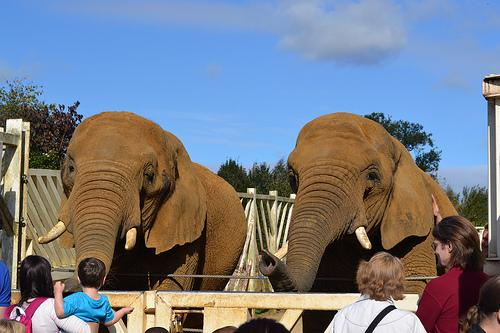Explain the interaction between the elephants and their surroundings. Two elephants stand behind a white metal fence with diagonal slats in their zoo enclosure, surrounded by green trees and observed by visitors. Write a brief description of the scene in the image. Two elephants are relaxing in a zoo enclosure, surrounded by a white fence and leafy trees, as several people, including a mother and child and a young boy in a blue shirt, look on. Describe the fencing that separates the elephants from the people. The fence is made of white metal and has diagonal slats, covering a width of 487 and height of 487. Provide a short description of the vegetation in the image. The image contains green leafy trees that appear to be located behind the fence holding in the elephants. What are the features of the people faces in the image? In the image, there's a red-shirted man wearing glasses and a child with a round face and eyes wide open looking at the elephants. Describe the hairstyles of the two individuals in the picture. There's a woman with brown medium length wavy hair, and a person with blonde hair on her head in the image. Mention the most dominant subject in the picture and one key feature of it. There are two large gray elephants in the image, one of them holding up its trunk playfully. 